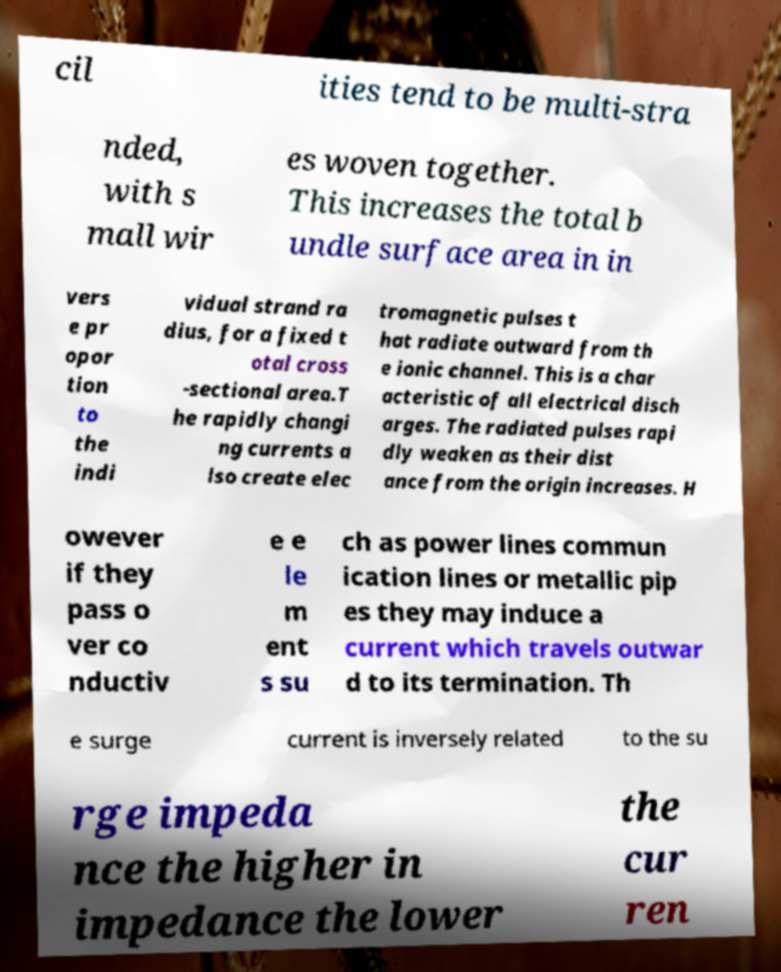Please read and relay the text visible in this image. What does it say? cil ities tend to be multi-stra nded, with s mall wir es woven together. This increases the total b undle surface area in in vers e pr opor tion to the indi vidual strand ra dius, for a fixed t otal cross -sectional area.T he rapidly changi ng currents a lso create elec tromagnetic pulses t hat radiate outward from th e ionic channel. This is a char acteristic of all electrical disch arges. The radiated pulses rapi dly weaken as their dist ance from the origin increases. H owever if they pass o ver co nductiv e e le m ent s su ch as power lines commun ication lines or metallic pip es they may induce a current which travels outwar d to its termination. Th e surge current is inversely related to the su rge impeda nce the higher in impedance the lower the cur ren 